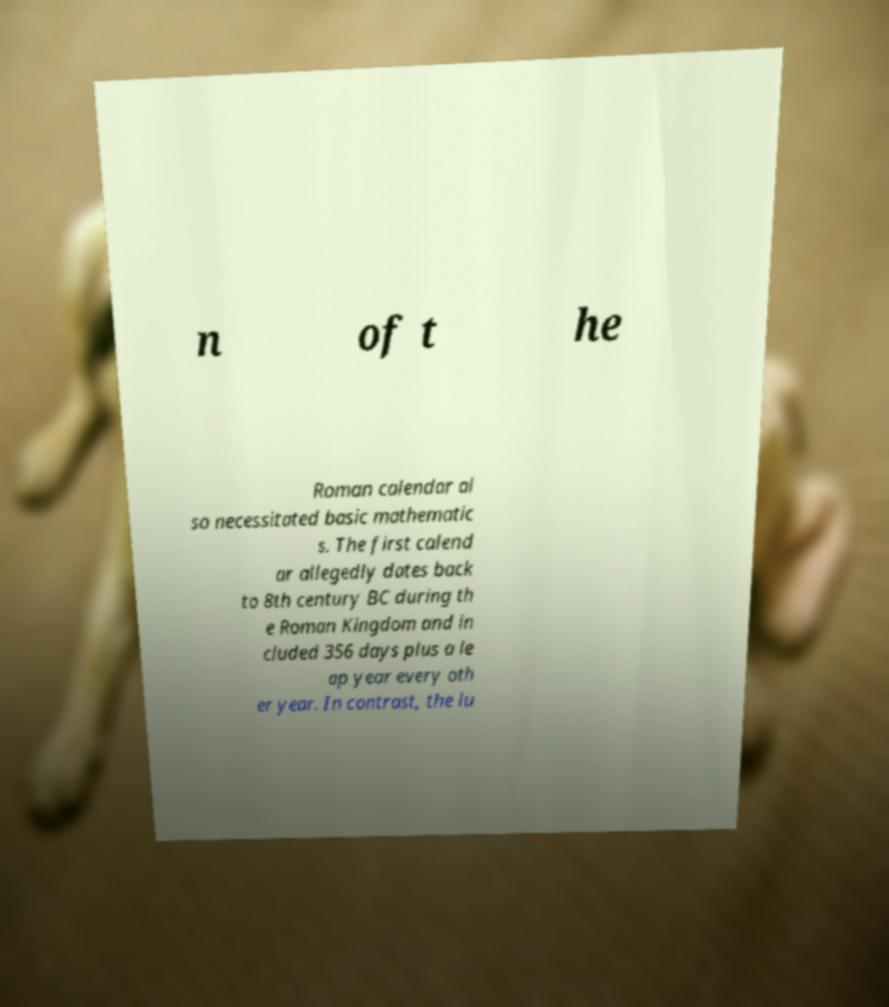Please read and relay the text visible in this image. What does it say? n of t he Roman calendar al so necessitated basic mathematic s. The first calend ar allegedly dates back to 8th century BC during th e Roman Kingdom and in cluded 356 days plus a le ap year every oth er year. In contrast, the lu 